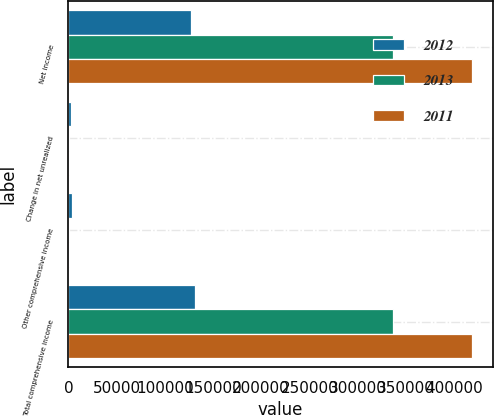Convert chart. <chart><loc_0><loc_0><loc_500><loc_500><stacked_bar_chart><ecel><fcel>Net income<fcel>Change in net unrealized<fcel>Other comprehensive income<fcel>Total comprehensive income<nl><fcel>2012<fcel>127389<fcel>2343<fcel>3834<fcel>131223<nl><fcel>2013<fcel>336705<fcel>256<fcel>256<fcel>336449<nl><fcel>2011<fcel>418950<fcel>325<fcel>325<fcel>419275<nl></chart> 